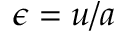<formula> <loc_0><loc_0><loc_500><loc_500>\epsilon = u / a</formula> 